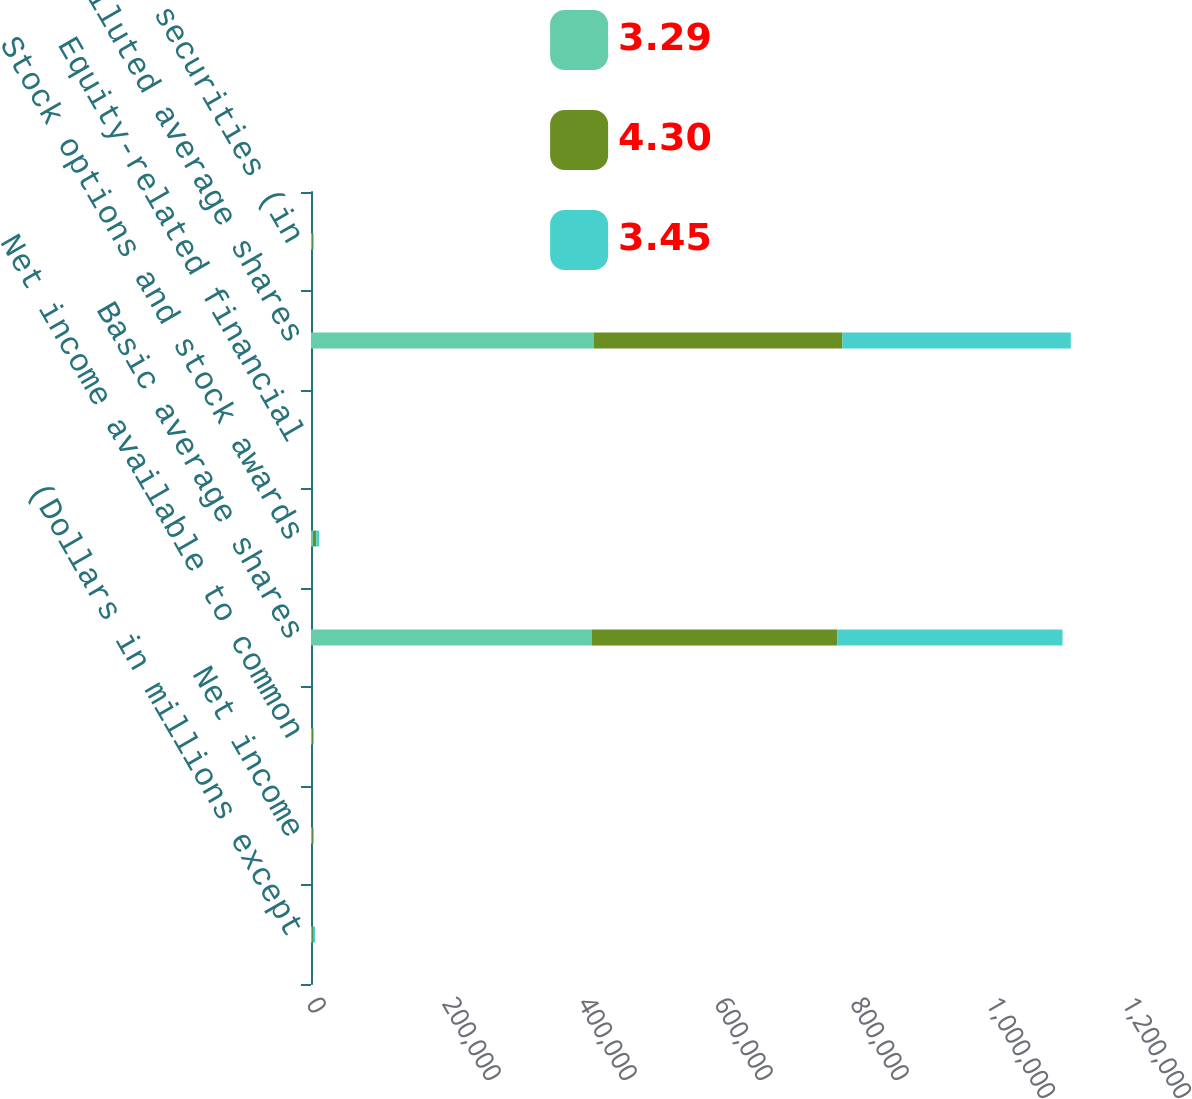<chart> <loc_0><loc_0><loc_500><loc_500><stacked_bar_chart><ecel><fcel>(Dollars in millions except<fcel>Net income<fcel>Net income available to common<fcel>Basic average shares<fcel>Stock options and stock awards<fcel>Equity-related financial<fcel>Diluted average shares<fcel>Anti-dilutive securities (in<nl><fcel>3.29<fcel>2008<fcel>1811<fcel>1789<fcel>413182<fcel>2910<fcel>8<fcel>416100<fcel>2012<nl><fcel>4.3<fcel>2007<fcel>1261<fcel>1261<fcel>360675<fcel>4788<fcel>25<fcel>365488<fcel>1091<nl><fcel>3.45<fcel>2006<fcel>1106<fcel>1106<fcel>331350<fcel>4349<fcel>33<fcel>335732<fcel>973<nl></chart> 